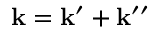Convert formula to latex. <formula><loc_0><loc_0><loc_500><loc_500>k = k ^ { \prime } + k ^ { \prime \prime }</formula> 